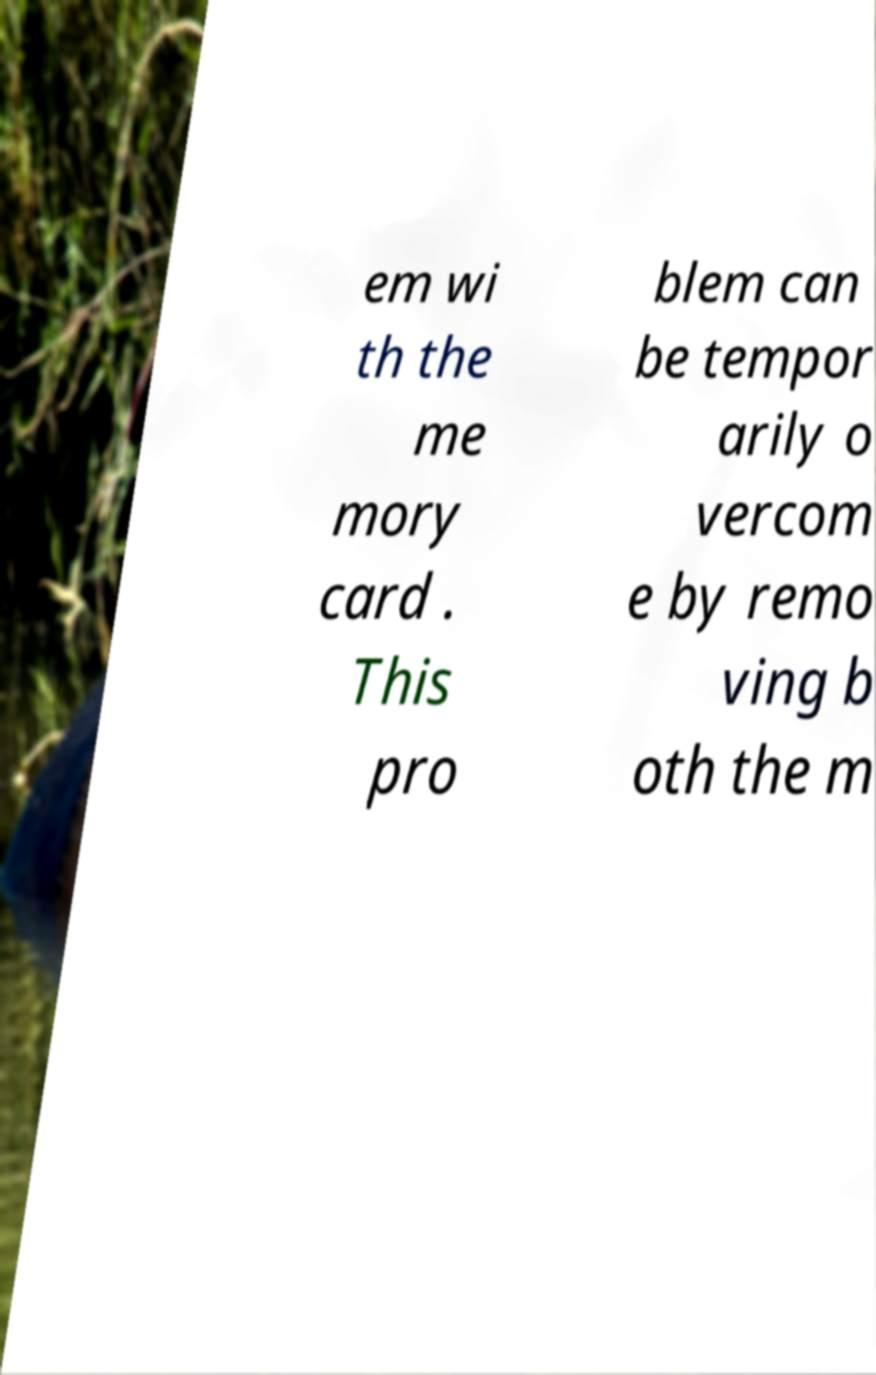Please identify and transcribe the text found in this image. em wi th the me mory card . This pro blem can be tempor arily o vercom e by remo ving b oth the m 